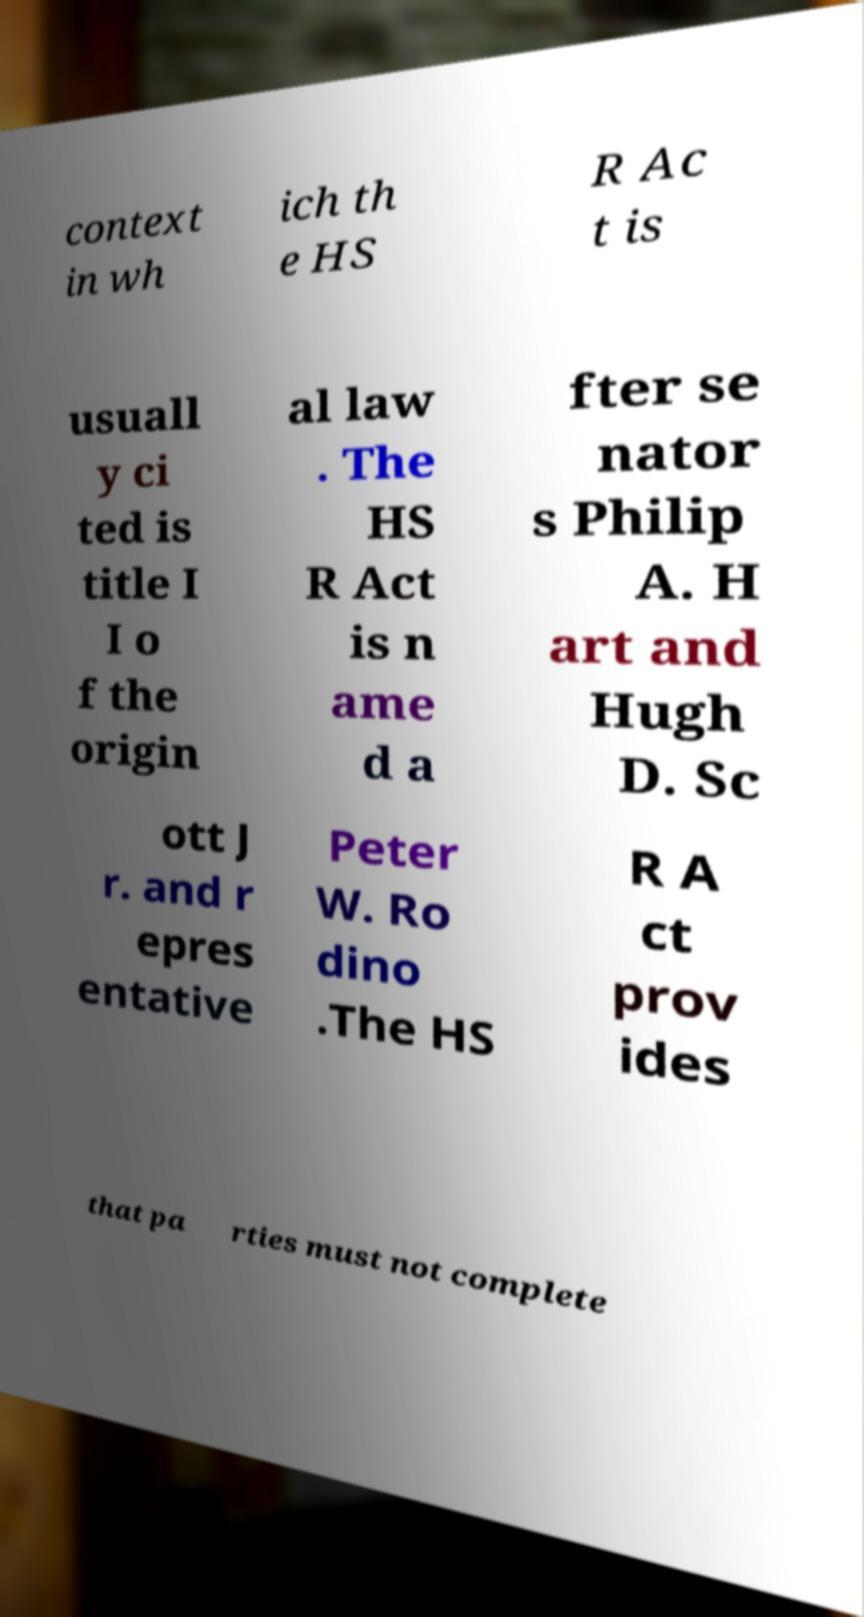Can you accurately transcribe the text from the provided image for me? context in wh ich th e HS R Ac t is usuall y ci ted is title I I o f the origin al law . The HS R Act is n ame d a fter se nator s Philip A. H art and Hugh D. Sc ott J r. and r epres entative Peter W. Ro dino .The HS R A ct prov ides that pa rties must not complete 